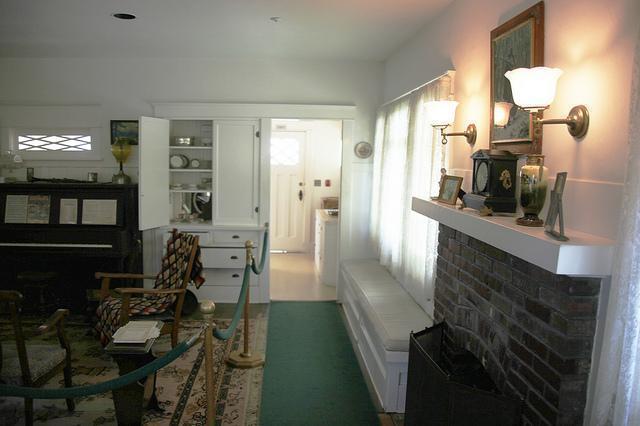What item is under the bright lights attached to the wall?
Choose the right answer and clarify with the format: 'Answer: answer
Rationale: rationale.'
Options: Oven, washing machine, fireplace, cat. Answer: fireplace.
Rationale: This is a living room, not a kitchen or laundry room. there is no cat. 